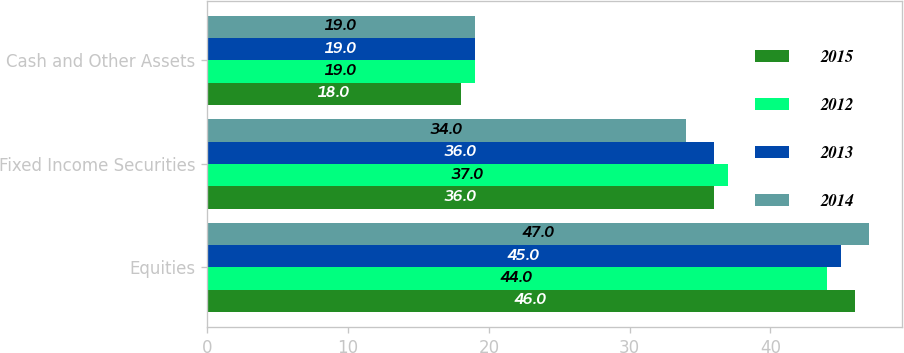Convert chart to OTSL. <chart><loc_0><loc_0><loc_500><loc_500><stacked_bar_chart><ecel><fcel>Equities<fcel>Fixed Income Securities<fcel>Cash and Other Assets<nl><fcel>2015<fcel>46<fcel>36<fcel>18<nl><fcel>2012<fcel>44<fcel>37<fcel>19<nl><fcel>2013<fcel>45<fcel>36<fcel>19<nl><fcel>2014<fcel>47<fcel>34<fcel>19<nl></chart> 